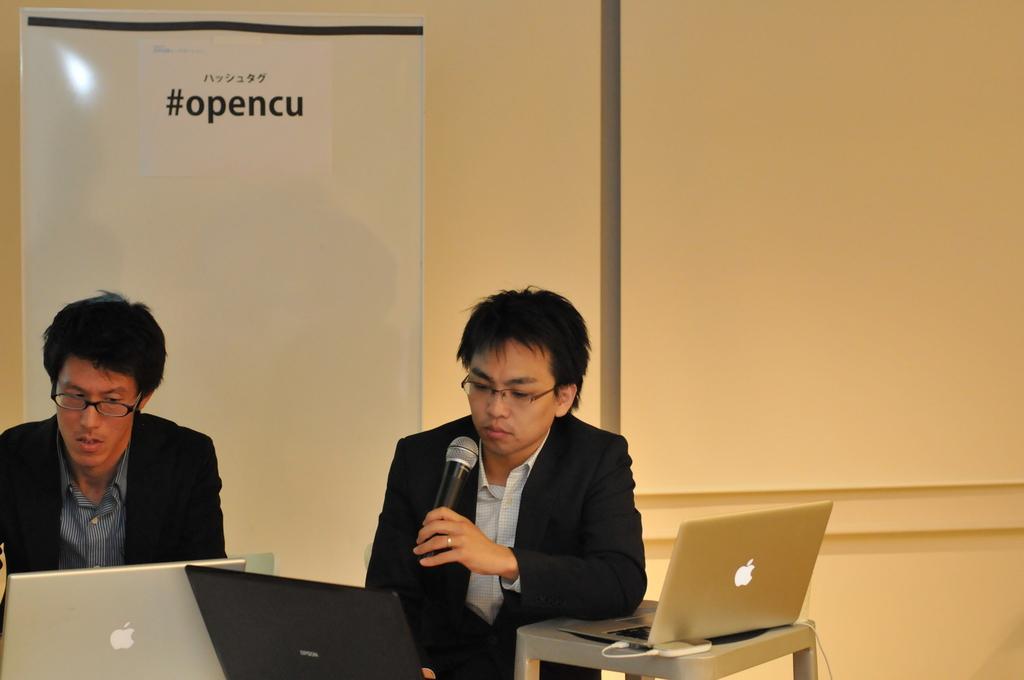Could you give a brief overview of what you see in this image? This is an inside view. On the left side, I can see two men are wearing black color suits, sitting and looking into the laptops. The man who is on the right side is holding a mike in hand. In front of him there is a table on which I can see a laptop. In the background, I can see a white color banner which is attached to a wall. 